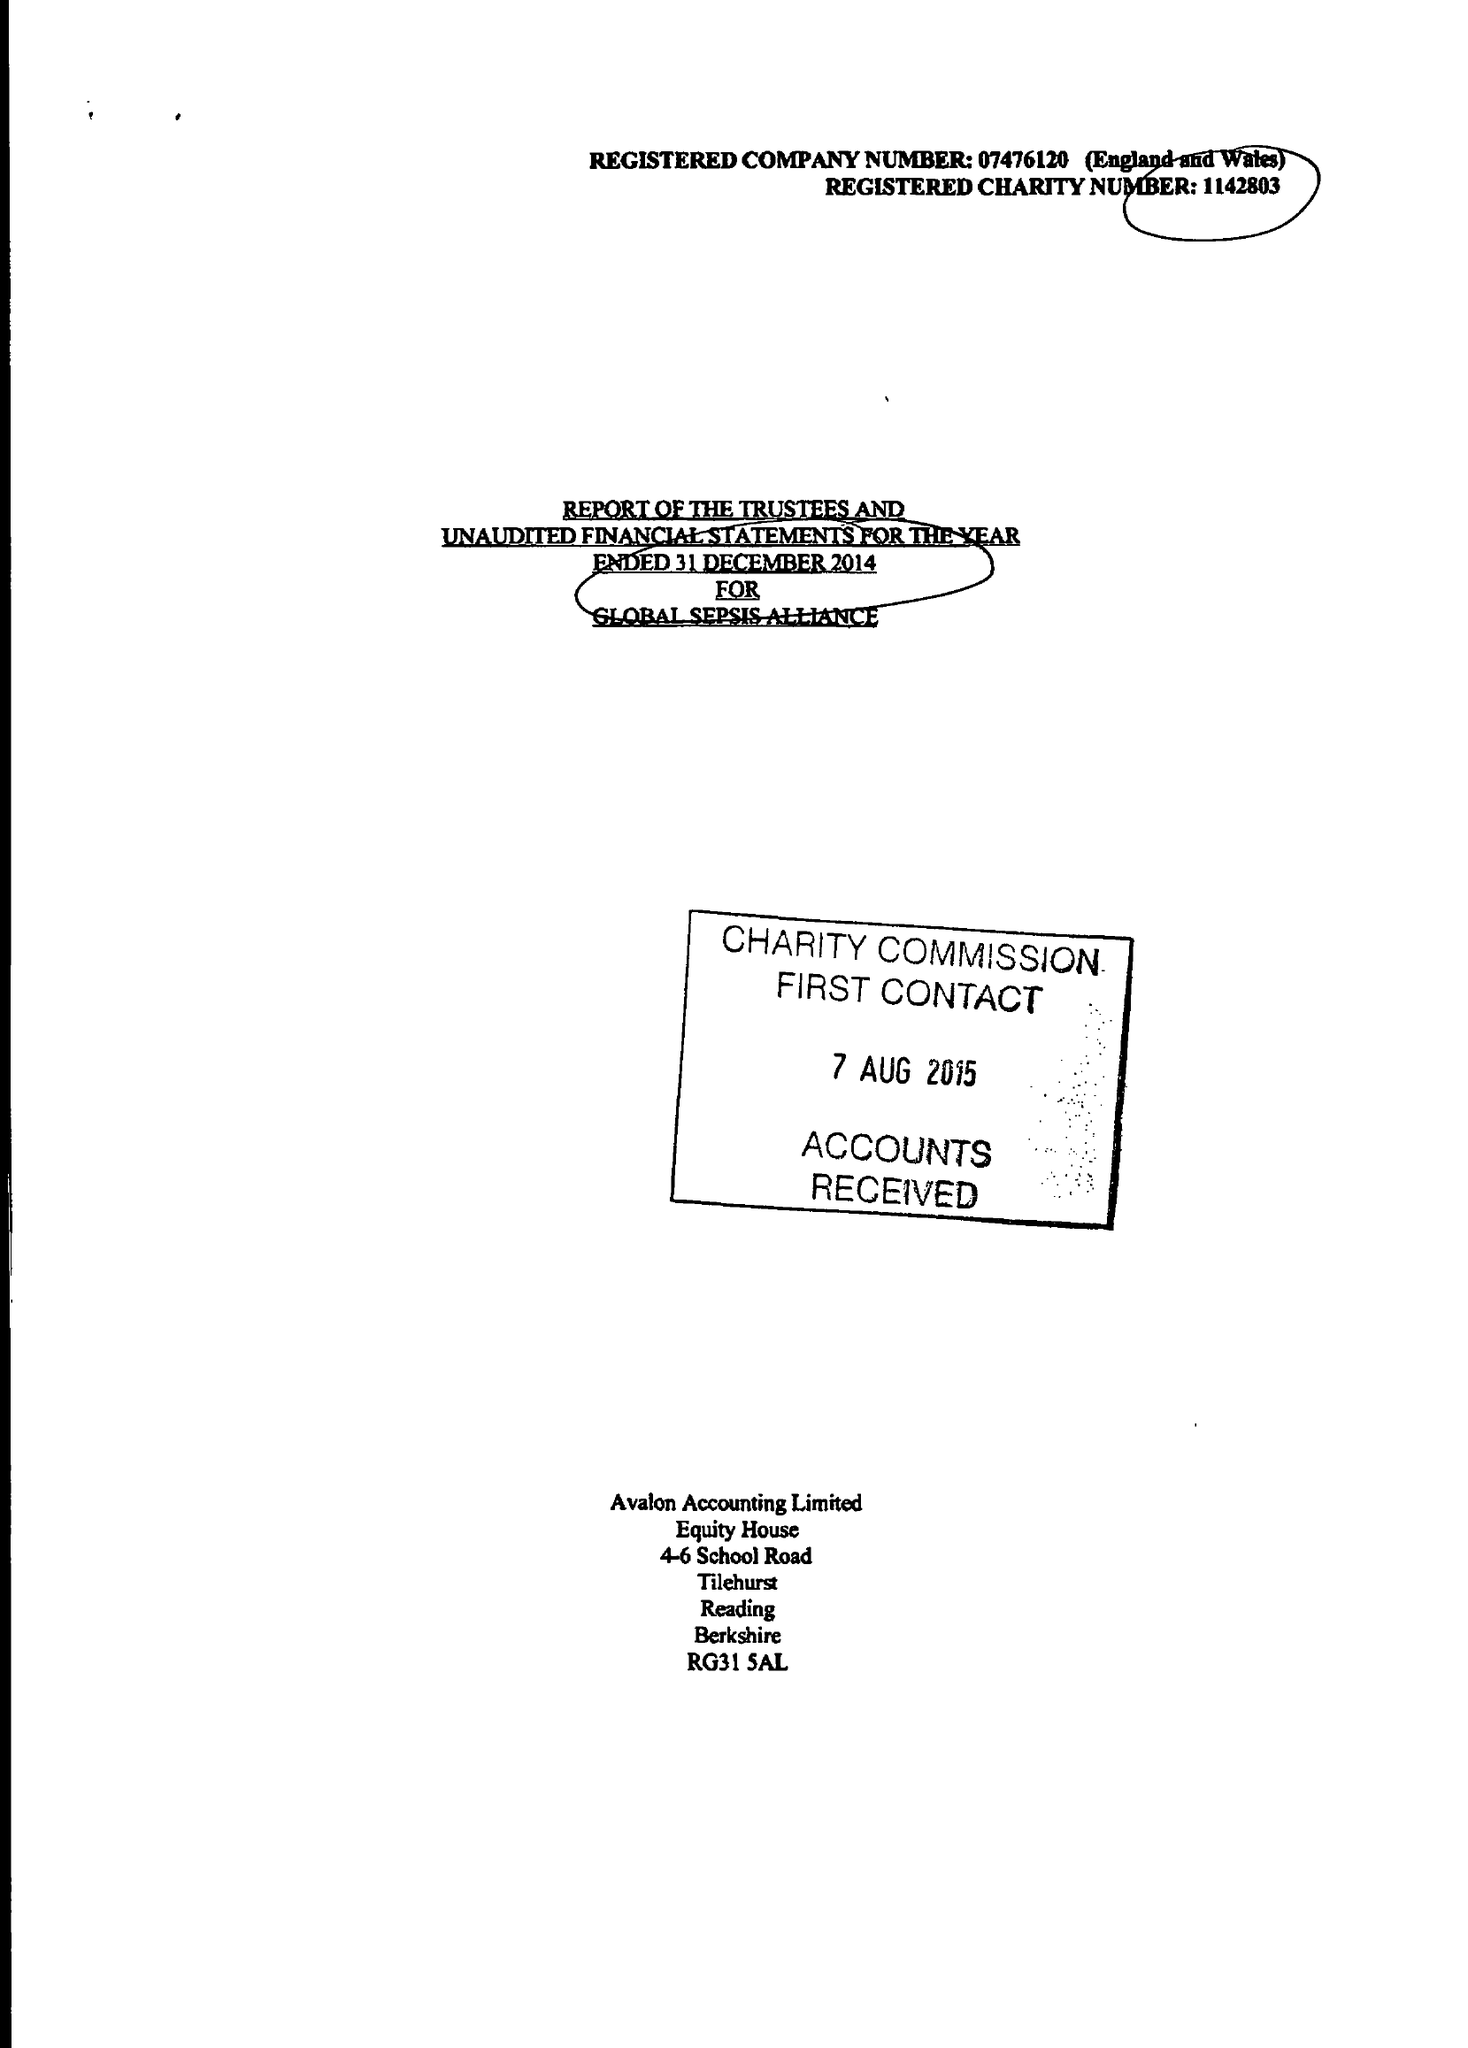What is the value for the charity_name?
Answer the question using a single word or phrase. Global Sepsis Alliance 